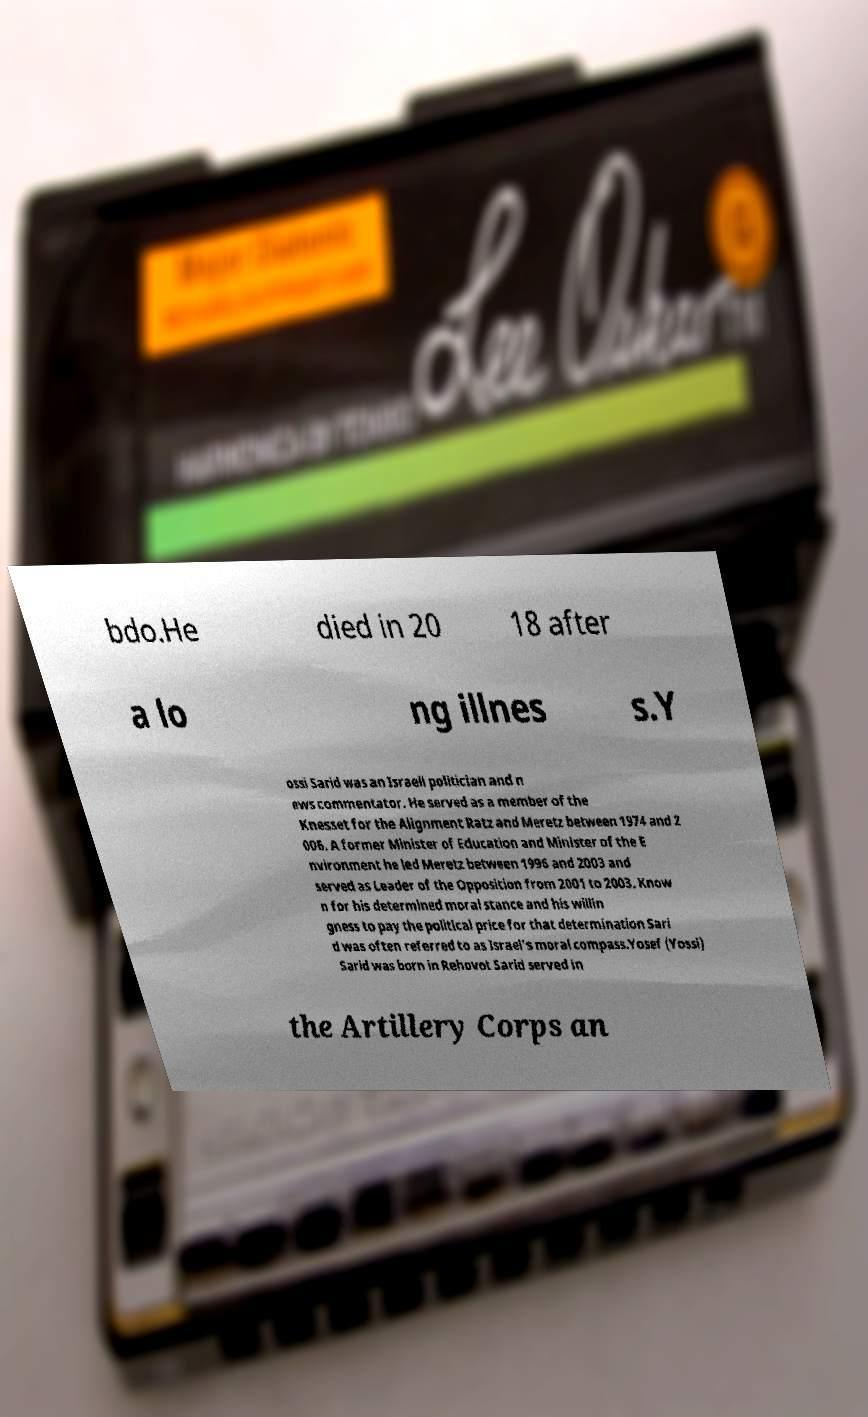Can you accurately transcribe the text from the provided image for me? bdo.He died in 20 18 after a lo ng illnes s.Y ossi Sarid was an Israeli politician and n ews commentator. He served as a member of the Knesset for the Alignment Ratz and Meretz between 1974 and 2 006. A former Minister of Education and Minister of the E nvironment he led Meretz between 1996 and 2003 and served as Leader of the Opposition from 2001 to 2003. Know n for his determined moral stance and his willin gness to pay the political price for that determination Sari d was often referred to as Israel's moral compass.Yosef (Yossi) Sarid was born in Rehovot Sarid served in the Artillery Corps an 